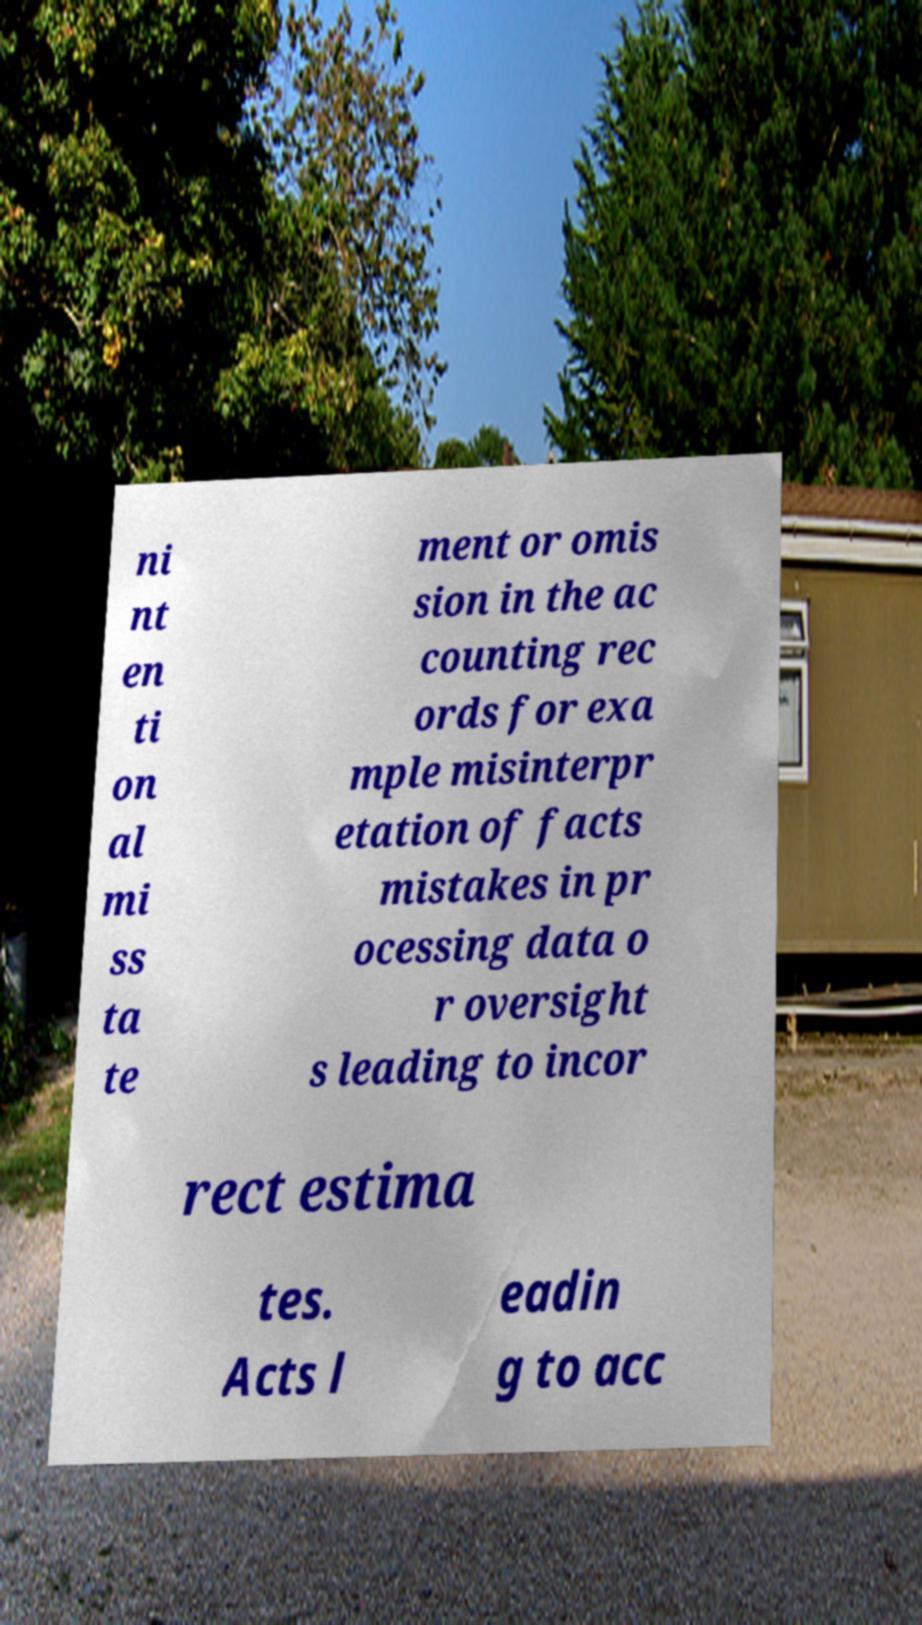Can you accurately transcribe the text from the provided image for me? ni nt en ti on al mi ss ta te ment or omis sion in the ac counting rec ords for exa mple misinterpr etation of facts mistakes in pr ocessing data o r oversight s leading to incor rect estima tes. Acts l eadin g to acc 